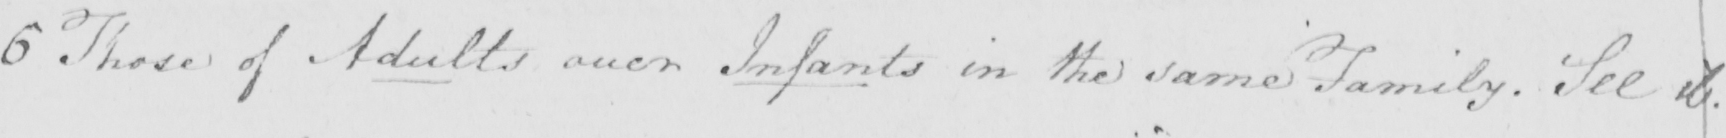What text is written in this handwritten line? 6 Those of Adults over Infants in the same Family . See ib . 